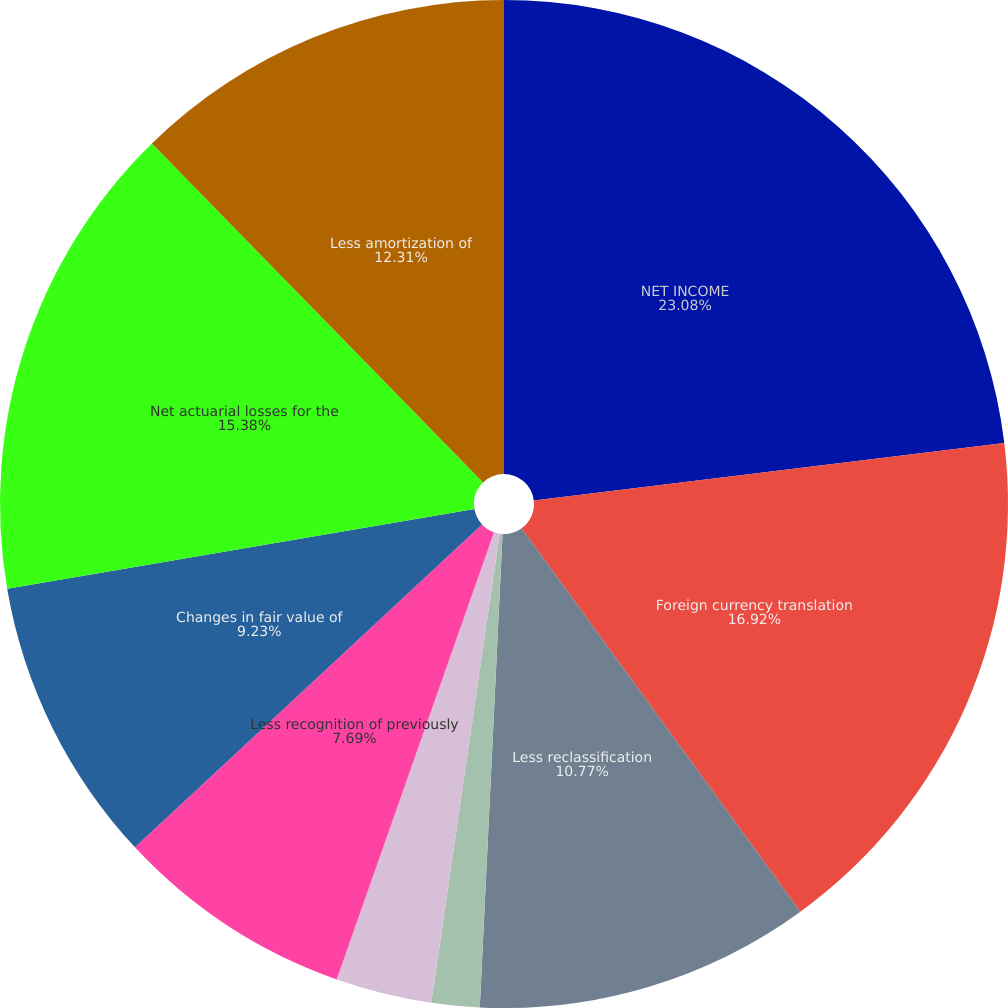<chart> <loc_0><loc_0><loc_500><loc_500><pie_chart><fcel>NET INCOME<fcel>Foreign currency translation<fcel>Less reclassification<fcel>Income tax effect<fcel>Changes in market value of<fcel>Less recognition of previously<fcel>Changes in fair value of<fcel>Net actuarial losses for the<fcel>Less amortization of<nl><fcel>23.07%<fcel>16.92%<fcel>10.77%<fcel>1.54%<fcel>3.08%<fcel>7.69%<fcel>9.23%<fcel>15.38%<fcel>12.31%<nl></chart> 